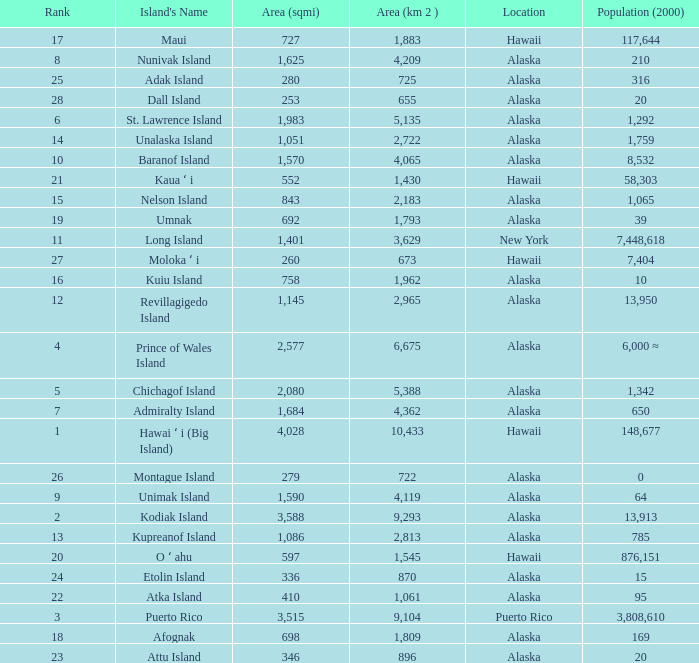What is the largest rank with 2,080 area? 5.0. 